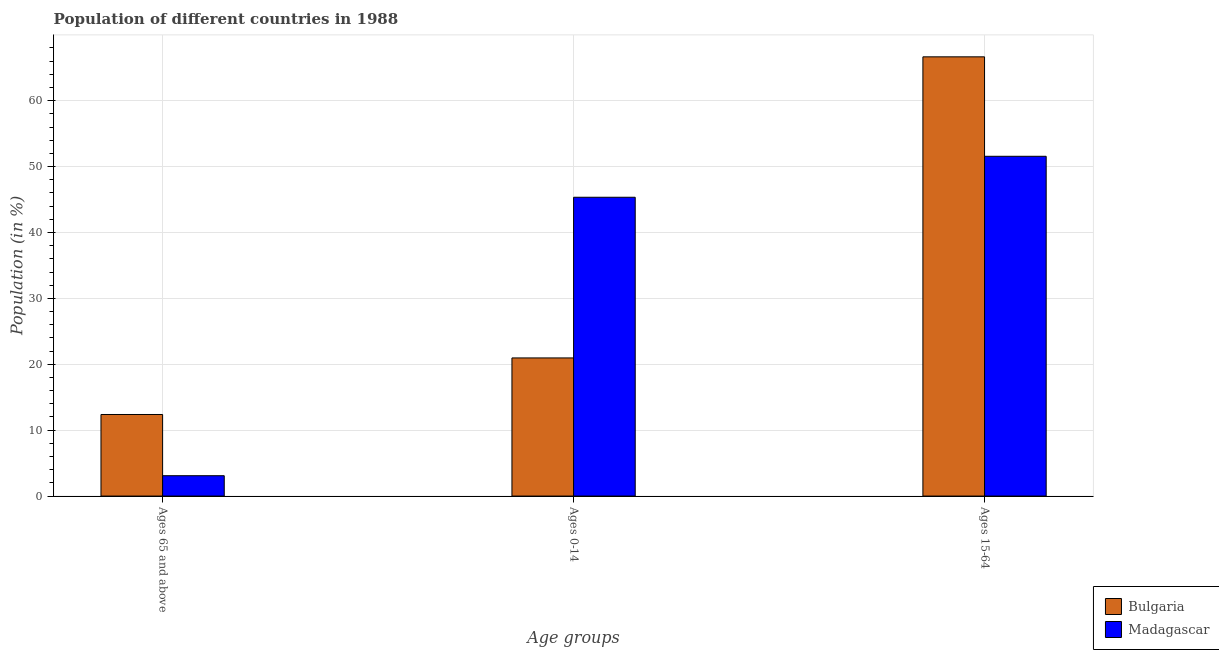How many groups of bars are there?
Make the answer very short. 3. Are the number of bars on each tick of the X-axis equal?
Keep it short and to the point. Yes. How many bars are there on the 2nd tick from the left?
Offer a terse response. 2. How many bars are there on the 3rd tick from the right?
Keep it short and to the point. 2. What is the label of the 2nd group of bars from the left?
Provide a succinct answer. Ages 0-14. What is the percentage of population within the age-group of 65 and above in Madagascar?
Keep it short and to the point. 3.09. Across all countries, what is the maximum percentage of population within the age-group of 65 and above?
Your response must be concise. 12.38. Across all countries, what is the minimum percentage of population within the age-group 0-14?
Provide a short and direct response. 20.96. In which country was the percentage of population within the age-group 15-64 maximum?
Give a very brief answer. Bulgaria. What is the total percentage of population within the age-group 15-64 in the graph?
Keep it short and to the point. 118.22. What is the difference between the percentage of population within the age-group 15-64 in Bulgaria and that in Madagascar?
Your answer should be very brief. 15.09. What is the difference between the percentage of population within the age-group of 65 and above in Bulgaria and the percentage of population within the age-group 15-64 in Madagascar?
Offer a terse response. -39.18. What is the average percentage of population within the age-group of 65 and above per country?
Provide a short and direct response. 7.74. What is the difference between the percentage of population within the age-group of 65 and above and percentage of population within the age-group 0-14 in Bulgaria?
Keep it short and to the point. -8.58. What is the ratio of the percentage of population within the age-group 15-64 in Bulgaria to that in Madagascar?
Your response must be concise. 1.29. Is the difference between the percentage of population within the age-group of 65 and above in Bulgaria and Madagascar greater than the difference between the percentage of population within the age-group 0-14 in Bulgaria and Madagascar?
Your answer should be compact. Yes. What is the difference between the highest and the second highest percentage of population within the age-group 0-14?
Make the answer very short. 24.38. What is the difference between the highest and the lowest percentage of population within the age-group 15-64?
Give a very brief answer. 15.09. In how many countries, is the percentage of population within the age-group of 65 and above greater than the average percentage of population within the age-group of 65 and above taken over all countries?
Make the answer very short. 1. What does the 2nd bar from the left in Ages 65 and above represents?
Keep it short and to the point. Madagascar. What does the 1st bar from the right in Ages 65 and above represents?
Give a very brief answer. Madagascar. Are all the bars in the graph horizontal?
Give a very brief answer. No. What is the difference between two consecutive major ticks on the Y-axis?
Your answer should be compact. 10. Are the values on the major ticks of Y-axis written in scientific E-notation?
Make the answer very short. No. Does the graph contain any zero values?
Your response must be concise. No. Does the graph contain grids?
Your answer should be compact. Yes. How many legend labels are there?
Offer a very short reply. 2. How are the legend labels stacked?
Ensure brevity in your answer.  Vertical. What is the title of the graph?
Offer a terse response. Population of different countries in 1988. Does "Korea (Republic)" appear as one of the legend labels in the graph?
Offer a terse response. No. What is the label or title of the X-axis?
Ensure brevity in your answer.  Age groups. What is the Population (in %) of Bulgaria in Ages 65 and above?
Make the answer very short. 12.38. What is the Population (in %) in Madagascar in Ages 65 and above?
Your response must be concise. 3.09. What is the Population (in %) in Bulgaria in Ages 0-14?
Provide a short and direct response. 20.96. What is the Population (in %) in Madagascar in Ages 0-14?
Your answer should be very brief. 45.35. What is the Population (in %) in Bulgaria in Ages 15-64?
Offer a very short reply. 66.66. What is the Population (in %) in Madagascar in Ages 15-64?
Your answer should be compact. 51.56. Across all Age groups, what is the maximum Population (in %) of Bulgaria?
Your answer should be very brief. 66.66. Across all Age groups, what is the maximum Population (in %) of Madagascar?
Keep it short and to the point. 51.56. Across all Age groups, what is the minimum Population (in %) in Bulgaria?
Your response must be concise. 12.38. Across all Age groups, what is the minimum Population (in %) in Madagascar?
Your answer should be very brief. 3.09. What is the total Population (in %) in Bulgaria in the graph?
Your answer should be compact. 100. What is the total Population (in %) in Madagascar in the graph?
Your answer should be compact. 100. What is the difference between the Population (in %) of Bulgaria in Ages 65 and above and that in Ages 0-14?
Make the answer very short. -8.58. What is the difference between the Population (in %) in Madagascar in Ages 65 and above and that in Ages 0-14?
Your answer should be very brief. -42.26. What is the difference between the Population (in %) in Bulgaria in Ages 65 and above and that in Ages 15-64?
Give a very brief answer. -54.28. What is the difference between the Population (in %) of Madagascar in Ages 65 and above and that in Ages 15-64?
Make the answer very short. -48.47. What is the difference between the Population (in %) of Bulgaria in Ages 0-14 and that in Ages 15-64?
Provide a short and direct response. -45.69. What is the difference between the Population (in %) in Madagascar in Ages 0-14 and that in Ages 15-64?
Your answer should be very brief. -6.22. What is the difference between the Population (in %) in Bulgaria in Ages 65 and above and the Population (in %) in Madagascar in Ages 0-14?
Provide a short and direct response. -32.97. What is the difference between the Population (in %) of Bulgaria in Ages 65 and above and the Population (in %) of Madagascar in Ages 15-64?
Keep it short and to the point. -39.18. What is the difference between the Population (in %) in Bulgaria in Ages 0-14 and the Population (in %) in Madagascar in Ages 15-64?
Provide a succinct answer. -30.6. What is the average Population (in %) of Bulgaria per Age groups?
Make the answer very short. 33.33. What is the average Population (in %) of Madagascar per Age groups?
Offer a very short reply. 33.33. What is the difference between the Population (in %) of Bulgaria and Population (in %) of Madagascar in Ages 65 and above?
Keep it short and to the point. 9.29. What is the difference between the Population (in %) of Bulgaria and Population (in %) of Madagascar in Ages 0-14?
Offer a very short reply. -24.38. What is the difference between the Population (in %) in Bulgaria and Population (in %) in Madagascar in Ages 15-64?
Provide a succinct answer. 15.09. What is the ratio of the Population (in %) in Bulgaria in Ages 65 and above to that in Ages 0-14?
Offer a very short reply. 0.59. What is the ratio of the Population (in %) in Madagascar in Ages 65 and above to that in Ages 0-14?
Keep it short and to the point. 0.07. What is the ratio of the Population (in %) in Bulgaria in Ages 65 and above to that in Ages 15-64?
Your response must be concise. 0.19. What is the ratio of the Population (in %) of Madagascar in Ages 65 and above to that in Ages 15-64?
Make the answer very short. 0.06. What is the ratio of the Population (in %) in Bulgaria in Ages 0-14 to that in Ages 15-64?
Provide a succinct answer. 0.31. What is the ratio of the Population (in %) in Madagascar in Ages 0-14 to that in Ages 15-64?
Your answer should be compact. 0.88. What is the difference between the highest and the second highest Population (in %) in Bulgaria?
Give a very brief answer. 45.69. What is the difference between the highest and the second highest Population (in %) of Madagascar?
Provide a succinct answer. 6.22. What is the difference between the highest and the lowest Population (in %) of Bulgaria?
Provide a succinct answer. 54.28. What is the difference between the highest and the lowest Population (in %) in Madagascar?
Offer a very short reply. 48.47. 